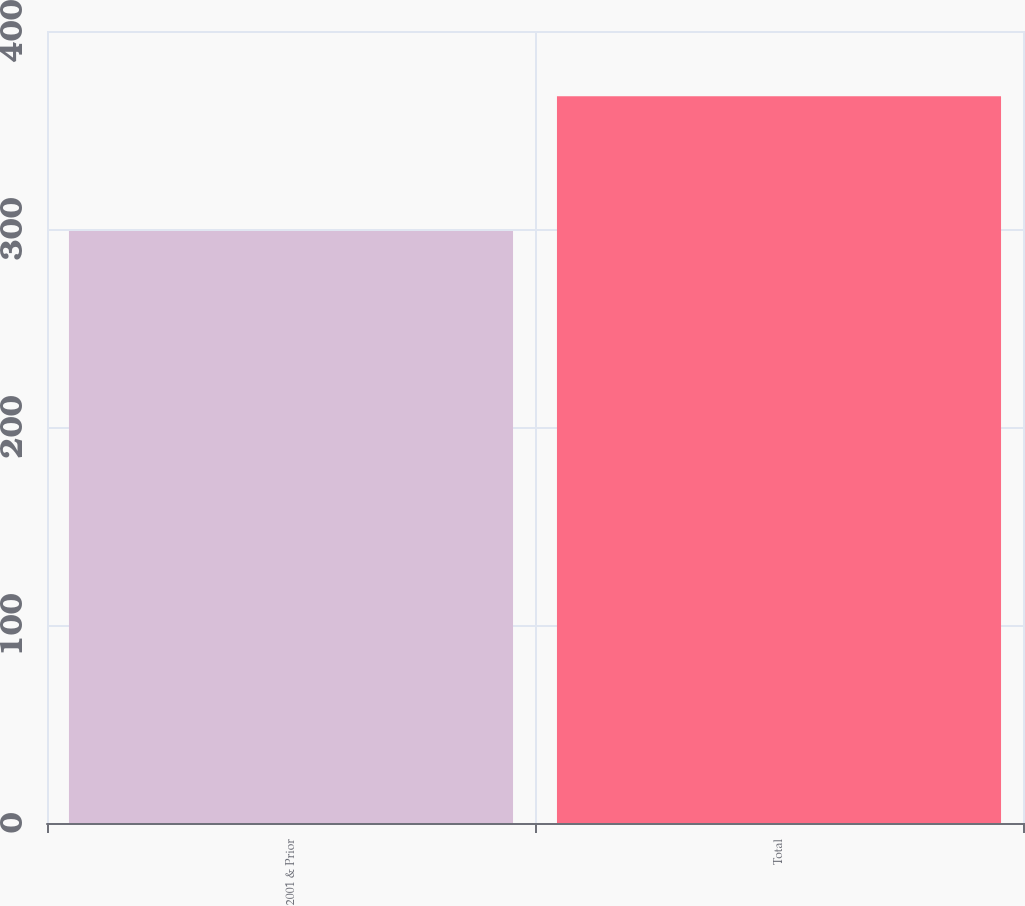Convert chart. <chart><loc_0><loc_0><loc_500><loc_500><bar_chart><fcel>2001 & Prior<fcel>Total<nl><fcel>299<fcel>367<nl></chart> 